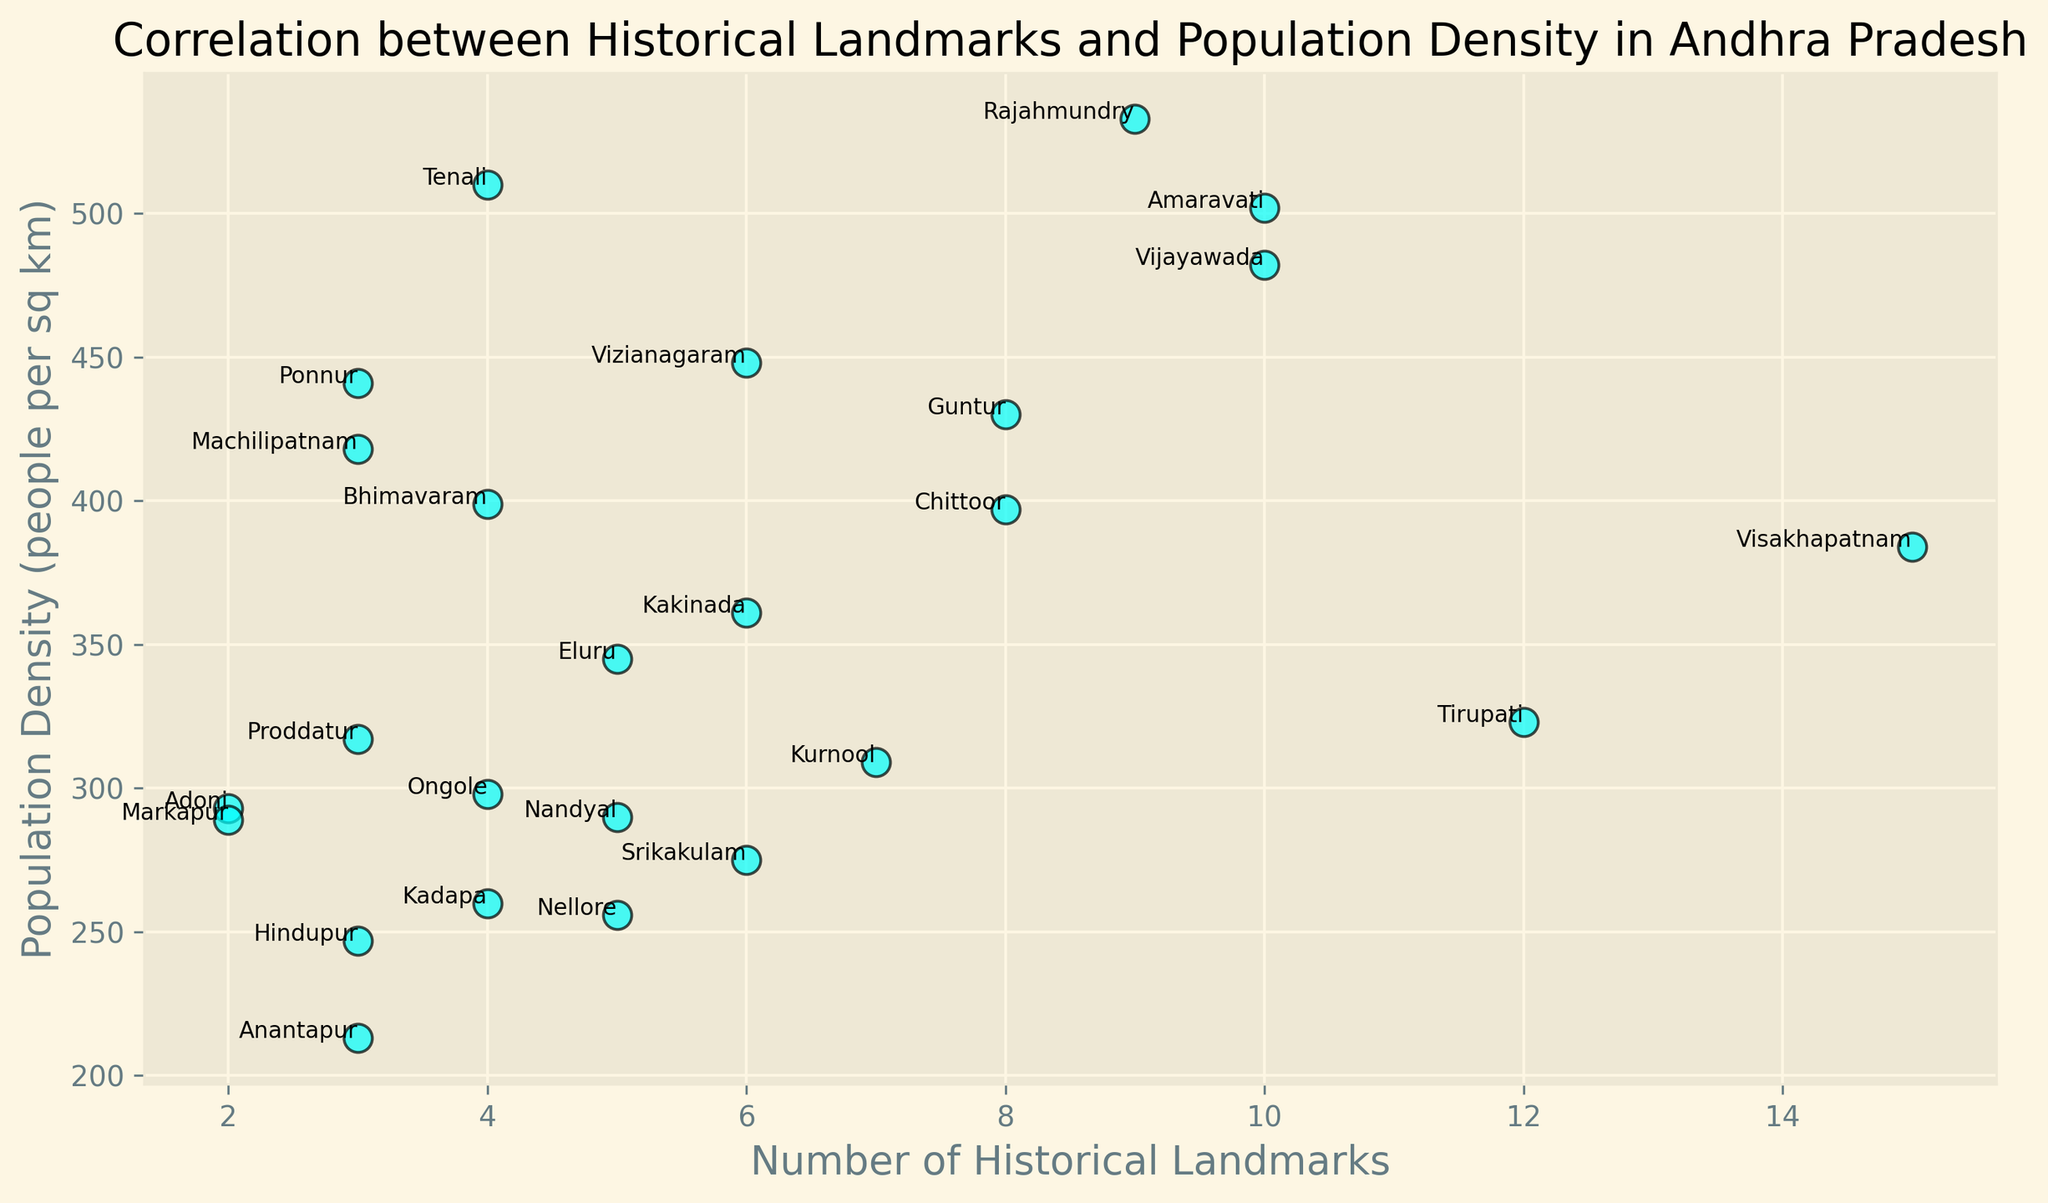Which district has the highest number of historical landmarks? To find the district with the highest number of historical landmarks, look for the data point with the highest value on the x-axis. The district with the highest value is Visakhapatnam with 15 historical landmarks.
Answer: Visakhapatnam Which district has the highest population density? To determine this, look for the data point with the highest value on the y-axis. Vijayawada has the highest population density at 482 people per sq km.
Answer: Vijayawada Which district has the lowest number of historical landmarks? Check the data point with the smallest value on the x-axis. Adoni has the fewest historical landmarks with 2.
Answer: Adoni Which district has the lowest population density? To find this district, look for the data point closest to the bottom of the scatter plot. Markapur has the lowest population density with 289 people per sq km.
Answer: Markapur What is the combined population density of the districts with exactly 10 historical landmarks? Identify the population densities of the districts with 10 historical landmarks from the plot, which are Vijayawada and Amaravati, then sum those values. The combined population density is 482 (Vijayawada) + 502 (Amaravati) = 984.
Answer: 984 Which district has more historical landmarks, Guntur or Machilipatnam? Compare the x-axis values for Guntur and Machilipatnam. Guntur has 8 historical landmarks, while Machilipatnam has 3.
Answer: Guntur What is the average population density of districts with at least 8 historical landmarks? Identify the population densities for the districts with at least 8 historical landmarks: Visakhapatnam (384), Vijayawada (482), Guntur (430), Tirupati (323), Rajahmundry (533), Chittoor (397), Amaravati (502). Sum these densities and divide by the number of districts: (384 + 482 + 430 + 323 + 533 + 397 + 502) / 7. The average is (3051 / 7) ≈ 436.
Answer: 436 How many districts have more than 8 historical landmarks and a population density above 400? Identify the districts with more than 8 historical landmarks and then check their population densities to see which ones are above 400. These districts are Vijayawada, Guntur, Rajahmundry, and Amaravati. There are 4 such districts.
Answer: 4 Which districts have more historical landmarks, on average: those with population density above 400 or below 400? Calculate the average number of historical landmarks for both groups:
- Above 400: Vijayawada (10), Guntur (8), Rajahmundry (9), Amaravati (10), Vizianagaram (6), Tenali (4) => Average is (10+8+9+10+6+4)/6 ≈ 7.83
- Below 400: Visakhapatnam (15), Tirupati (12), Kurnool (7), Kadapa (4), Anantapur (3), Nellore (5), Srikakulam (6), Chittoor (8), Eluru (5), Machilipatnam (3), Ongole (4), Kakinada (6), Proddatur (3), Adoni (2), Markapur (2), Ponnur (3), Bhimavaram (4) => Average is (15+12+7+4+3+5+6+8+5+3+4+6+3+2+2+3+4)/17 ≈ 5.12
The average number of historical landmarks is higher for districts with a population density above 400.
Answer: Above 400 